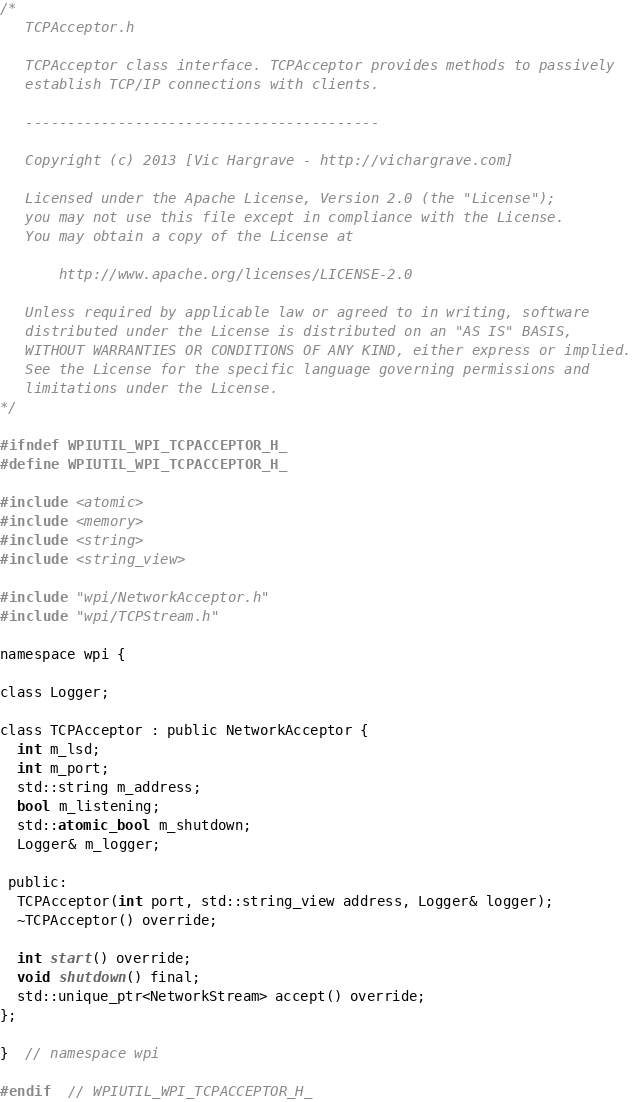Convert code to text. <code><loc_0><loc_0><loc_500><loc_500><_C_>/*
   TCPAcceptor.h

   TCPAcceptor class interface. TCPAcceptor provides methods to passively
   establish TCP/IP connections with clients.

   ------------------------------------------

   Copyright (c) 2013 [Vic Hargrave - http://vichargrave.com]

   Licensed under the Apache License, Version 2.0 (the "License");
   you may not use this file except in compliance with the License.
   You may obtain a copy of the License at

       http://www.apache.org/licenses/LICENSE-2.0

   Unless required by applicable law or agreed to in writing, software
   distributed under the License is distributed on an "AS IS" BASIS,
   WITHOUT WARRANTIES OR CONDITIONS OF ANY KIND, either express or implied.
   See the License for the specific language governing permissions and
   limitations under the License.
*/

#ifndef WPIUTIL_WPI_TCPACCEPTOR_H_
#define WPIUTIL_WPI_TCPACCEPTOR_H_

#include <atomic>
#include <memory>
#include <string>
#include <string_view>

#include "wpi/NetworkAcceptor.h"
#include "wpi/TCPStream.h"

namespace wpi {

class Logger;

class TCPAcceptor : public NetworkAcceptor {
  int m_lsd;
  int m_port;
  std::string m_address;
  bool m_listening;
  std::atomic_bool m_shutdown;
  Logger& m_logger;

 public:
  TCPAcceptor(int port, std::string_view address, Logger& logger);
  ~TCPAcceptor() override;

  int start() override;
  void shutdown() final;
  std::unique_ptr<NetworkStream> accept() override;
};

}  // namespace wpi

#endif  // WPIUTIL_WPI_TCPACCEPTOR_H_
</code> 